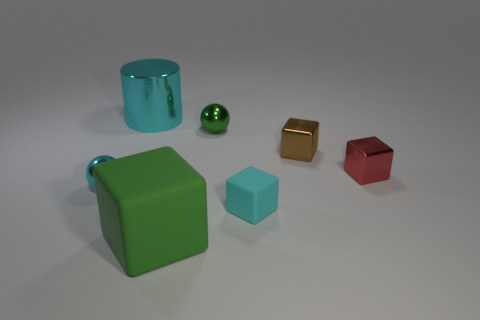Is there a big rubber thing that has the same color as the big cube?
Offer a very short reply. No. There is a tiny shiny ball to the left of the object that is behind the tiny green object; what is its color?
Make the answer very short. Cyan. Are there fewer cyan shiny objects that are to the right of the small red shiny block than big cubes that are behind the green cube?
Make the answer very short. No. Do the cyan rubber object and the metal cylinder have the same size?
Your response must be concise. No. The tiny metallic thing that is both to the left of the brown metallic cube and behind the red metallic cube has what shape?
Ensure brevity in your answer.  Sphere. How many brown blocks have the same material as the small cyan cube?
Your response must be concise. 0. There is a ball behind the tiny red thing; what number of cylinders are behind it?
Ensure brevity in your answer.  1. What is the shape of the cyan object that is to the right of the big object in front of the sphere in front of the small brown metal block?
Keep it short and to the point. Cube. What is the size of the block that is the same color as the large shiny cylinder?
Your answer should be compact. Small. What number of objects are tiny cyan blocks or large cyan rubber blocks?
Offer a very short reply. 1. 